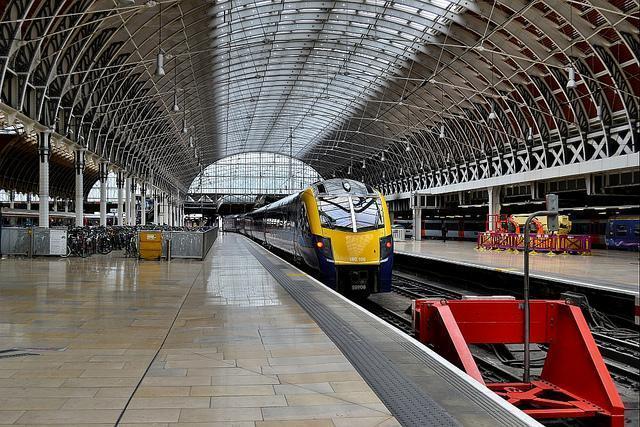How many people are visible?
Give a very brief answer. 0. 